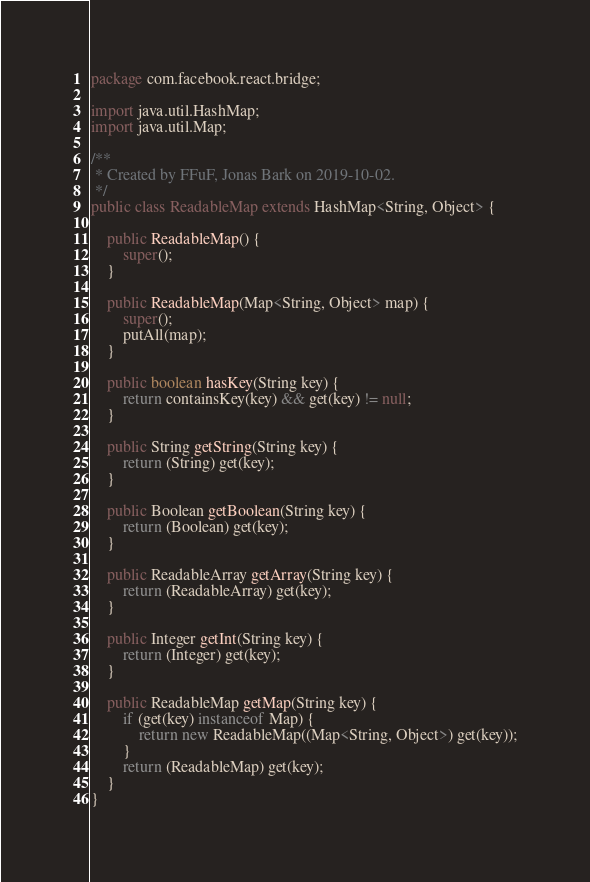<code> <loc_0><loc_0><loc_500><loc_500><_Java_>package com.facebook.react.bridge;

import java.util.HashMap;
import java.util.Map;

/**
 * Created by FFuF, Jonas Bark on 2019-10-02.
 */
public class ReadableMap extends HashMap<String, Object> {

    public ReadableMap() {
        super();
    }

    public ReadableMap(Map<String, Object> map) {
        super();
        putAll(map);
    }

    public boolean hasKey(String key) {
        return containsKey(key) && get(key) != null;
    }

    public String getString(String key) {
        return (String) get(key);
    }

    public Boolean getBoolean(String key) {
        return (Boolean) get(key);
    }

    public ReadableArray getArray(String key) {
        return (ReadableArray) get(key);
    }

    public Integer getInt(String key) {
        return (Integer) get(key);
    }

    public ReadableMap getMap(String key) {
        if (get(key) instanceof Map) {
            return new ReadableMap((Map<String, Object>) get(key));
        }
        return (ReadableMap) get(key);
    }
}
</code> 